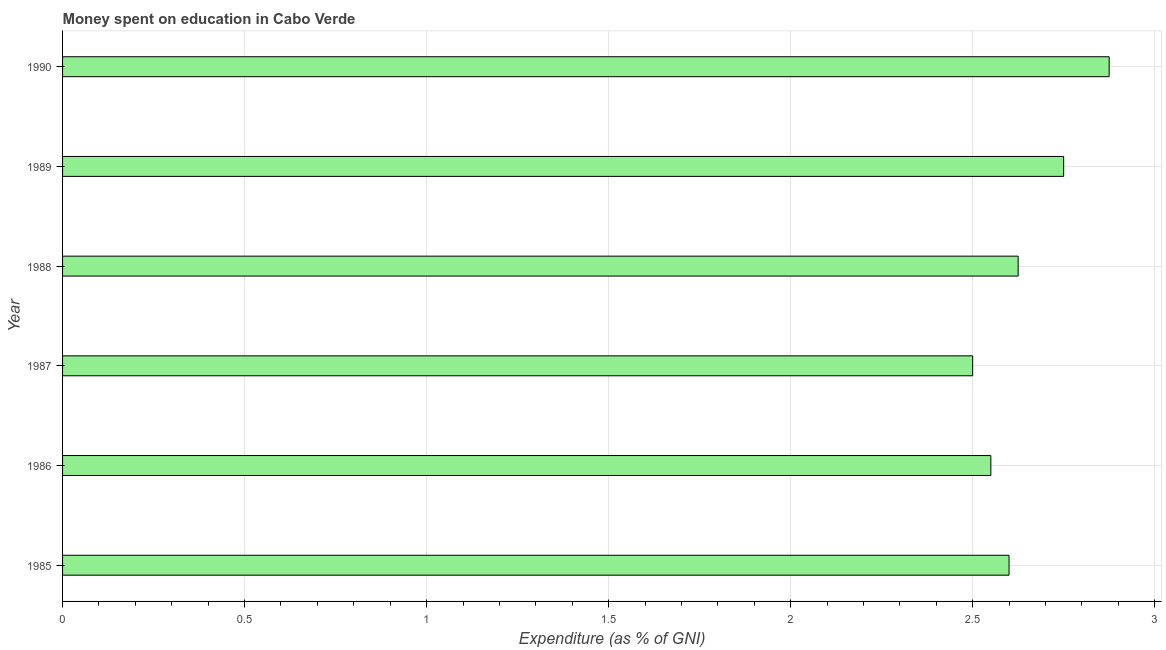Does the graph contain any zero values?
Offer a very short reply. No. What is the title of the graph?
Your response must be concise. Money spent on education in Cabo Verde. What is the label or title of the X-axis?
Give a very brief answer. Expenditure (as % of GNI). What is the label or title of the Y-axis?
Provide a succinct answer. Year. Across all years, what is the maximum expenditure on education?
Keep it short and to the point. 2.88. In which year was the expenditure on education minimum?
Offer a very short reply. 1987. What is the sum of the expenditure on education?
Give a very brief answer. 15.9. What is the average expenditure on education per year?
Provide a short and direct response. 2.65. What is the median expenditure on education?
Offer a terse response. 2.61. What is the ratio of the expenditure on education in 1987 to that in 1990?
Your response must be concise. 0.87. Is the sum of the expenditure on education in 1988 and 1990 greater than the maximum expenditure on education across all years?
Your response must be concise. Yes. What is the difference between the highest and the lowest expenditure on education?
Ensure brevity in your answer.  0.38. Are all the bars in the graph horizontal?
Offer a very short reply. Yes. What is the difference between two consecutive major ticks on the X-axis?
Your answer should be compact. 0.5. What is the Expenditure (as % of GNI) in 1985?
Offer a terse response. 2.6. What is the Expenditure (as % of GNI) in 1986?
Ensure brevity in your answer.  2.55. What is the Expenditure (as % of GNI) in 1988?
Your answer should be very brief. 2.62. What is the Expenditure (as % of GNI) of 1989?
Offer a very short reply. 2.75. What is the Expenditure (as % of GNI) of 1990?
Offer a very short reply. 2.88. What is the difference between the Expenditure (as % of GNI) in 1985 and 1988?
Keep it short and to the point. -0.03. What is the difference between the Expenditure (as % of GNI) in 1985 and 1989?
Give a very brief answer. -0.15. What is the difference between the Expenditure (as % of GNI) in 1985 and 1990?
Provide a succinct answer. -0.28. What is the difference between the Expenditure (as % of GNI) in 1986 and 1988?
Your response must be concise. -0.07. What is the difference between the Expenditure (as % of GNI) in 1986 and 1989?
Make the answer very short. -0.2. What is the difference between the Expenditure (as % of GNI) in 1986 and 1990?
Your response must be concise. -0.33. What is the difference between the Expenditure (as % of GNI) in 1987 and 1988?
Your answer should be very brief. -0.12. What is the difference between the Expenditure (as % of GNI) in 1987 and 1989?
Your response must be concise. -0.25. What is the difference between the Expenditure (as % of GNI) in 1987 and 1990?
Your answer should be very brief. -0.38. What is the difference between the Expenditure (as % of GNI) in 1988 and 1989?
Provide a succinct answer. -0.12. What is the difference between the Expenditure (as % of GNI) in 1989 and 1990?
Keep it short and to the point. -0.12. What is the ratio of the Expenditure (as % of GNI) in 1985 to that in 1986?
Your answer should be compact. 1.02. What is the ratio of the Expenditure (as % of GNI) in 1985 to that in 1988?
Offer a terse response. 0.99. What is the ratio of the Expenditure (as % of GNI) in 1985 to that in 1989?
Offer a terse response. 0.94. What is the ratio of the Expenditure (as % of GNI) in 1985 to that in 1990?
Offer a terse response. 0.9. What is the ratio of the Expenditure (as % of GNI) in 1986 to that in 1988?
Keep it short and to the point. 0.97. What is the ratio of the Expenditure (as % of GNI) in 1986 to that in 1989?
Your response must be concise. 0.93. What is the ratio of the Expenditure (as % of GNI) in 1986 to that in 1990?
Provide a short and direct response. 0.89. What is the ratio of the Expenditure (as % of GNI) in 1987 to that in 1988?
Provide a succinct answer. 0.95. What is the ratio of the Expenditure (as % of GNI) in 1987 to that in 1989?
Provide a succinct answer. 0.91. What is the ratio of the Expenditure (as % of GNI) in 1987 to that in 1990?
Your answer should be very brief. 0.87. What is the ratio of the Expenditure (as % of GNI) in 1988 to that in 1989?
Your answer should be very brief. 0.95. 